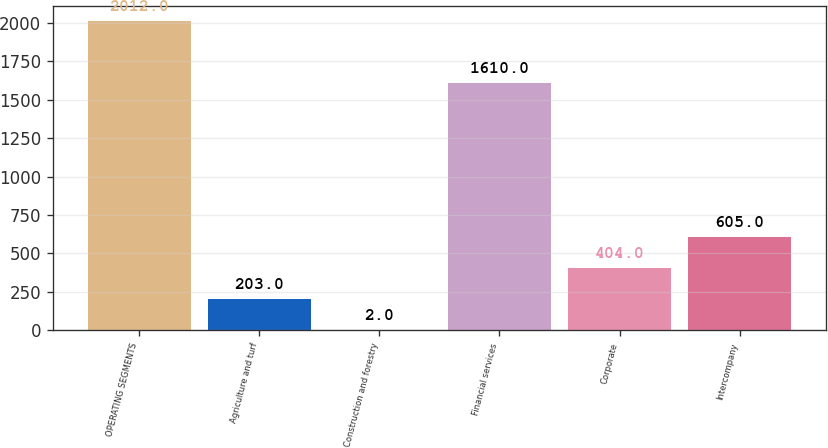<chart> <loc_0><loc_0><loc_500><loc_500><bar_chart><fcel>OPERATING SEGMENTS<fcel>Agriculture and turf<fcel>Construction and forestry<fcel>Financial services<fcel>Corporate<fcel>Intercompany<nl><fcel>2012<fcel>203<fcel>2<fcel>1610<fcel>404<fcel>605<nl></chart> 